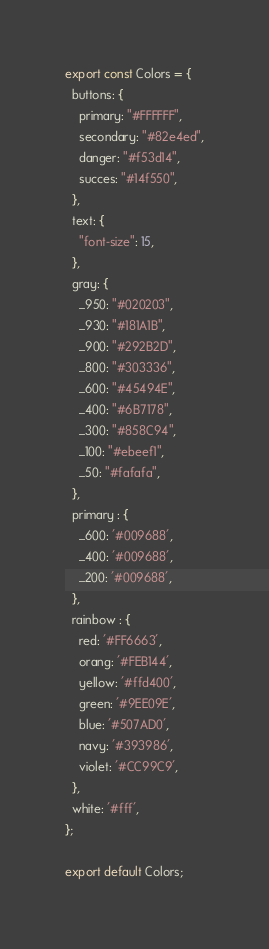Convert code to text. <code><loc_0><loc_0><loc_500><loc_500><_JavaScript_>export const Colors = {
  buttons: {
    primary: "#FFFFFF",
    secondary: "#82e4ed",
    danger: "#f53d14",
    succes: "#14f550",
  },
  text: {
    "font-size": 15,
  },
  gray: {
    _950: "#020203",
    _930: "#181A1B",
    _900: "#292B2D",
    _800: "#303336",
    _600: "#45494E",
    _400: "#6B7178",
    _300: "#858C94",
    _100: "#ebeef1",
    _50: "#fafafa",
  },
  primary : {
    _600: '#009688',
    _400: '#009688',
    _200: '#009688',
  },
  rainbow : {
    red: '#FF6663',
    orang: '#FEB144',
    yellow: '#ffd400',
    green: '#9EE09E',
    blue: '#507AD0',
    navy: '#393986',
    violet: '#CC99C9',
  },
  white: '#fff',
};

export default Colors;

</code> 